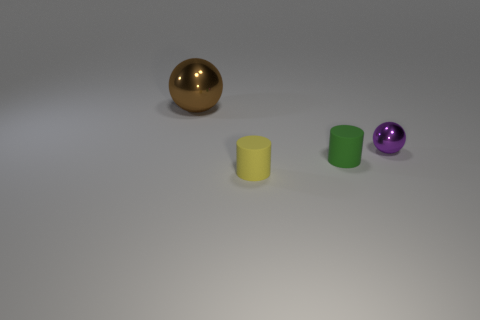Add 1 brown metal spheres. How many objects exist? 5 Subtract all green cylinders. How many cylinders are left? 1 Subtract 1 spheres. How many spheres are left? 1 Subtract 0 blue cylinders. How many objects are left? 4 Subtract all cyan balls. Subtract all gray cubes. How many balls are left? 2 Subtract all brown cylinders. How many blue balls are left? 0 Subtract all big things. Subtract all small yellow rubber objects. How many objects are left? 2 Add 1 yellow cylinders. How many yellow cylinders are left? 2 Add 3 tiny rubber cylinders. How many tiny rubber cylinders exist? 5 